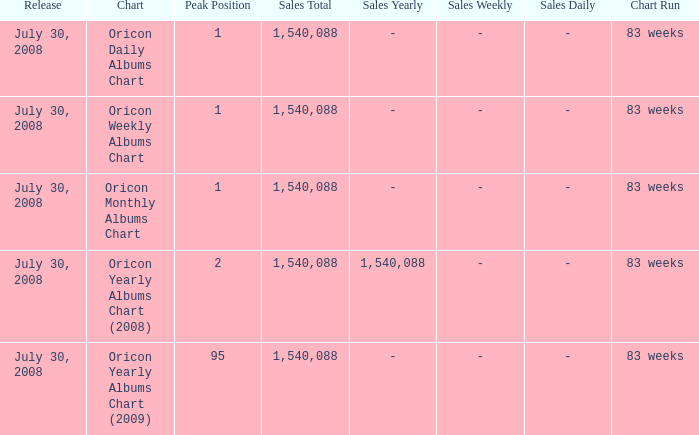Could you parse the entire table? {'header': ['Release', 'Chart', 'Peak Position', 'Sales Total', 'Sales Yearly', 'Sales Weekly', 'Sales Daily', 'Chart Run'], 'rows': [['July 30, 2008', 'Oricon Daily Albums Chart', '1', '1,540,088', '-', '-', '-', '83 weeks'], ['July 30, 2008', 'Oricon Weekly Albums Chart', '1', '1,540,088', '-', '-', '-', '83 weeks'], ['July 30, 2008', 'Oricon Monthly Albums Chart', '1', '1,540,088', '-', '-', '-', '83 weeks'], ['July 30, 2008', 'Oricon Yearly Albums Chart (2008)', '2', '1,540,088', '1,540,088', '-', '-', '83 weeks'], ['July 30, 2008', 'Oricon Yearly Albums Chart (2009)', '95', '1,540,088', '-', '-', '-', '83 weeks']]} How much Peak Position has Sales Total larger than 1,540,088? 0.0. 